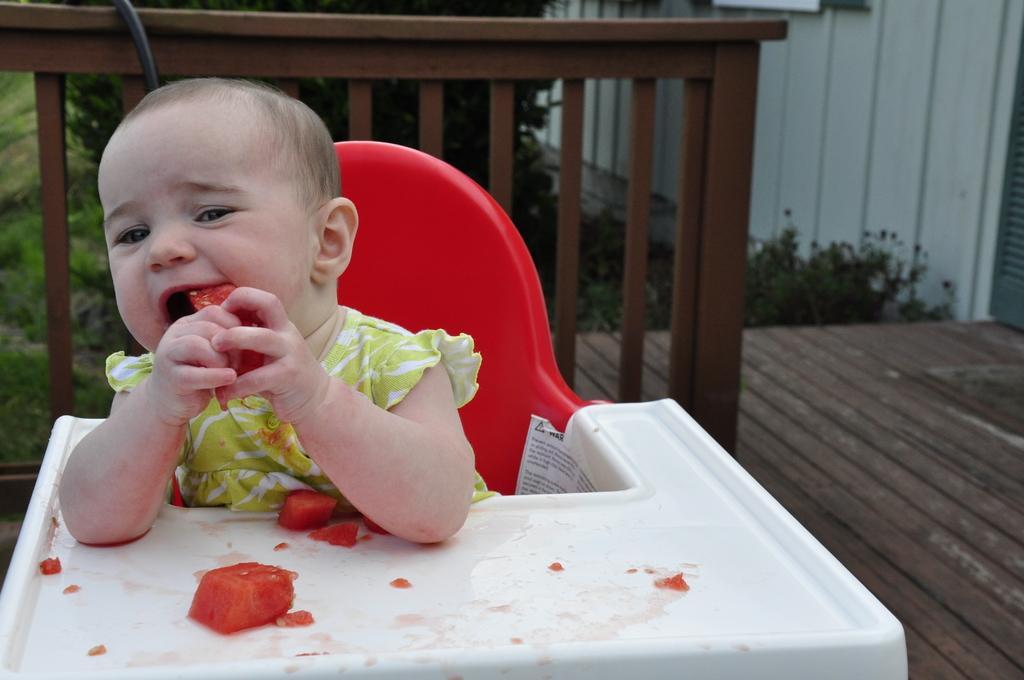How would you summarize this image in a sentence or two? In this image I can see the child sitting on the red color chair and eating the food which is in red color. In the back I can see the railing and the trees. 